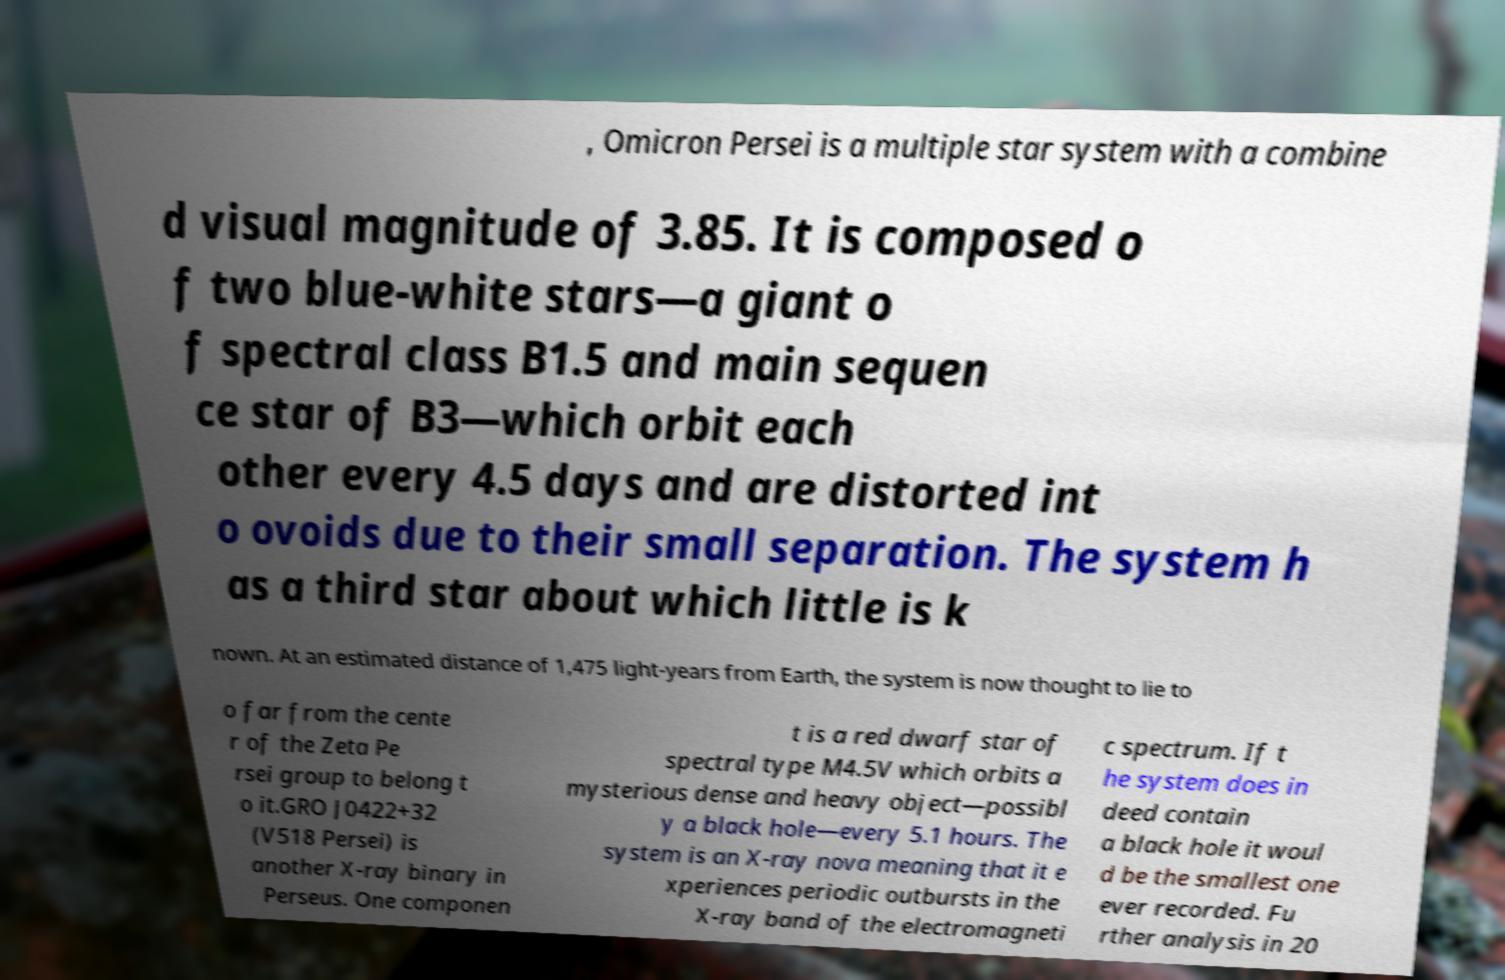Could you extract and type out the text from this image? , Omicron Persei is a multiple star system with a combine d visual magnitude of 3.85. It is composed o f two blue-white stars—a giant o f spectral class B1.5 and main sequen ce star of B3—which orbit each other every 4.5 days and are distorted int o ovoids due to their small separation. The system h as a third star about which little is k nown. At an estimated distance of 1,475 light-years from Earth, the system is now thought to lie to o far from the cente r of the Zeta Pe rsei group to belong t o it.GRO J0422+32 (V518 Persei) is another X-ray binary in Perseus. One componen t is a red dwarf star of spectral type M4.5V which orbits a mysterious dense and heavy object—possibl y a black hole—every 5.1 hours. The system is an X-ray nova meaning that it e xperiences periodic outbursts in the X-ray band of the electromagneti c spectrum. If t he system does in deed contain a black hole it woul d be the smallest one ever recorded. Fu rther analysis in 20 